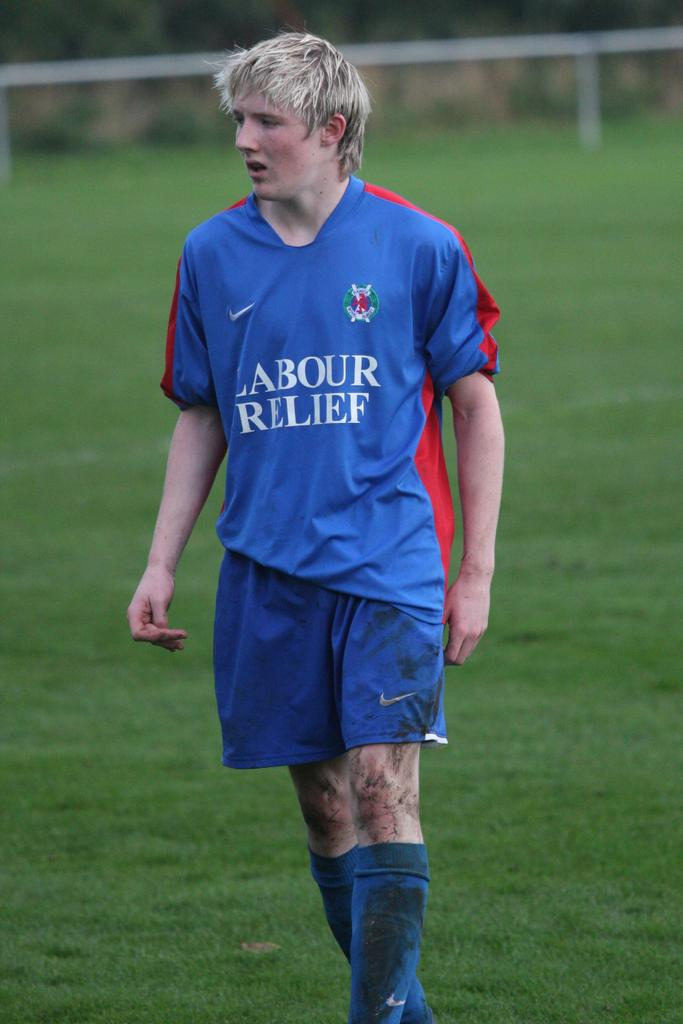<image>
Give a short and clear explanation of the subsequent image. A dirty soccer player with a blue uniform and the words Labour Relief on the front. 